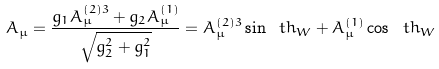Convert formula to latex. <formula><loc_0><loc_0><loc_500><loc_500>A _ { \mu } = \frac { g _ { 1 } A ^ { ( 2 ) 3 } _ { \mu } + g _ { 2 } A ^ { ( 1 ) } _ { \mu } } { \sqrt { g _ { 2 } ^ { 2 } + g _ { 1 } ^ { 2 } } } = A ^ { ( 2 ) 3 } _ { \mu } \sin \ t h _ { W } + A ^ { ( 1 ) } _ { \mu } \cos \ t h _ { W }</formula> 